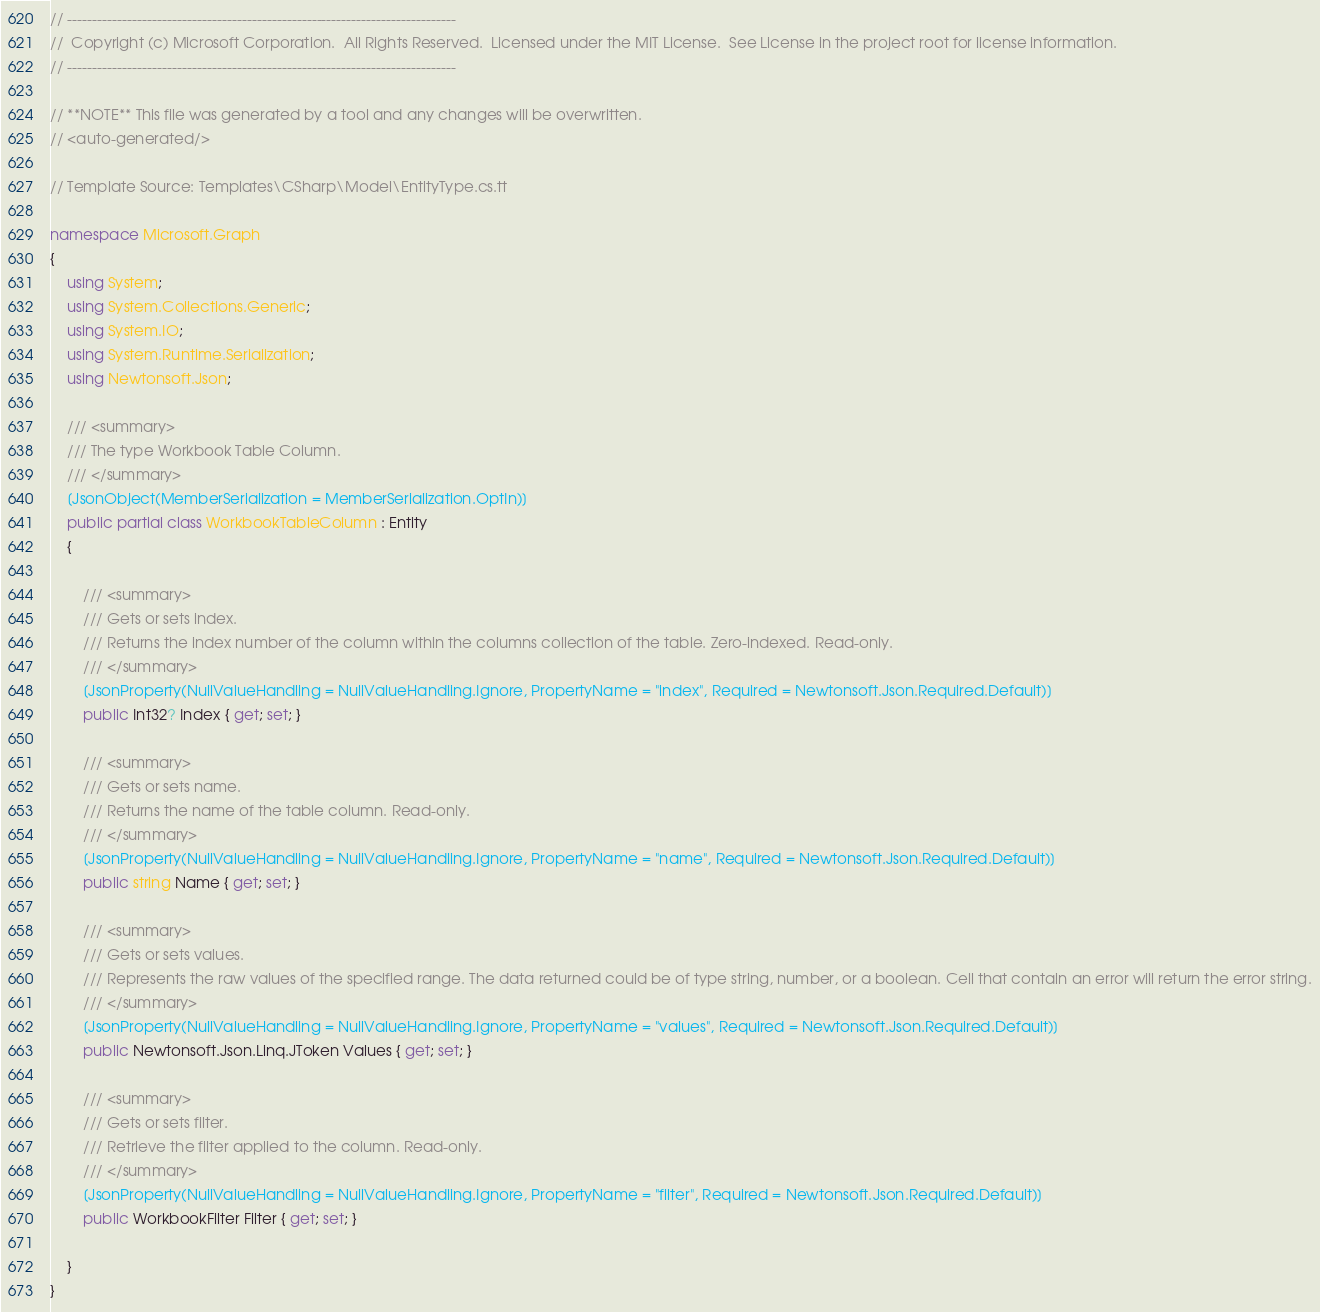<code> <loc_0><loc_0><loc_500><loc_500><_C#_>// ------------------------------------------------------------------------------
//  Copyright (c) Microsoft Corporation.  All Rights Reserved.  Licensed under the MIT License.  See License in the project root for license information.
// ------------------------------------------------------------------------------

// **NOTE** This file was generated by a tool and any changes will be overwritten.
// <auto-generated/>

// Template Source: Templates\CSharp\Model\EntityType.cs.tt

namespace Microsoft.Graph
{
    using System;
    using System.Collections.Generic;
    using System.IO;
    using System.Runtime.Serialization;
    using Newtonsoft.Json;

    /// <summary>
    /// The type Workbook Table Column.
    /// </summary>
    [JsonObject(MemberSerialization = MemberSerialization.OptIn)]
    public partial class WorkbookTableColumn : Entity
    {
    
        /// <summary>
        /// Gets or sets index.
        /// Returns the index number of the column within the columns collection of the table. Zero-indexed. Read-only.
        /// </summary>
        [JsonProperty(NullValueHandling = NullValueHandling.Ignore, PropertyName = "index", Required = Newtonsoft.Json.Required.Default)]
        public Int32? Index { get; set; }
    
        /// <summary>
        /// Gets or sets name.
        /// Returns the name of the table column. Read-only.
        /// </summary>
        [JsonProperty(NullValueHandling = NullValueHandling.Ignore, PropertyName = "name", Required = Newtonsoft.Json.Required.Default)]
        public string Name { get; set; }
    
        /// <summary>
        /// Gets or sets values.
        /// Represents the raw values of the specified range. The data returned could be of type string, number, or a boolean. Cell that contain an error will return the error string.
        /// </summary>
        [JsonProperty(NullValueHandling = NullValueHandling.Ignore, PropertyName = "values", Required = Newtonsoft.Json.Required.Default)]
        public Newtonsoft.Json.Linq.JToken Values { get; set; }
    
        /// <summary>
        /// Gets or sets filter.
        /// Retrieve the filter applied to the column. Read-only.
        /// </summary>
        [JsonProperty(NullValueHandling = NullValueHandling.Ignore, PropertyName = "filter", Required = Newtonsoft.Json.Required.Default)]
        public WorkbookFilter Filter { get; set; }
    
    }
}

</code> 